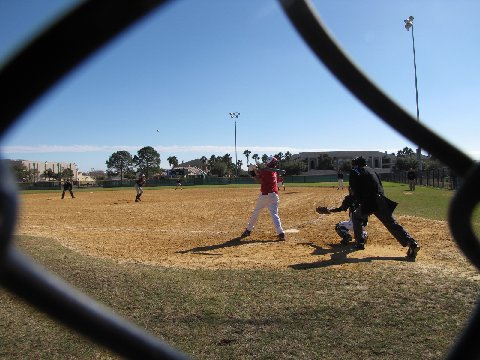What type of baseball game is being played in the image?
 The image shows a little league baseball game being played by several children outdoors in a field. What is the perspective from which the baseball game is being viewed? The baseball game is being viewed from behind a chain link fence, creating a sense of looking in on the action. What is one of the baseball players doing in the image? One of the baseball players, a young boy, is taking a swing with his bat during the game. What is another player doing during the game? Another baseball player is standing on top of the field, likely preparing for their turn to bat or focusing on the ongoing gameplay. What can you tell me about little league baseball games and their importance? Little league baseball games are organized youth baseball leagues tailored specifically for children, usually aged 4 to 16. These games provide a crucial platform for children to learn the fundamentals and rules of baseball in a structured and age-appropriate environment. Participation in such activities has several essential benefits for young children:

1. Physical Exercise: Little league baseball offers participants an opportunity to engage in regular physical activity, promoting overall health and fitness, and helping in the development of their motor skills, strength, and agility.

2. Social Skills: By participating in team sports, like little league baseball, children learn essential social skills that can later translate into other aspects of their lives. They learn about teamwork, communication, and collaboration with their peers, developing friendships and bonding with others who share their interests.

3. Life Skills: Little league baseball games encourage children to develop important life skills, such as discipline, time management, and goal-setting. They learn to handle success and failure, deal with competition, and cultivate good sportsmanship.

4. Emotional Growth: Playing in little league baseball games helps children build self-esteem, confidence, and resilience. They learn to take risks, cope with their emotions, and navigate complex social situations.

5. Fun and Enjoyment: Little league baseball games provide children with a chance to have fun and enjoy the sport in a safe, nurturing, and inclusive environment.

Overall, little league baseball serves not just as a recreational activity but as a significant platform for children's personal, social, and emotional development. Participation in little league games helps nurture well-rounded individuals who can go on to apply the valuable lessons and skills gained on the field to other aspects of their lives. 